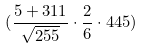Convert formula to latex. <formula><loc_0><loc_0><loc_500><loc_500>( \frac { 5 + 3 1 1 } { \sqrt { 2 5 5 } } \cdot \frac { 2 } { 6 } \cdot 4 4 5 )</formula> 